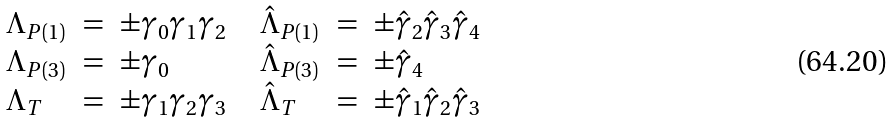<formula> <loc_0><loc_0><loc_500><loc_500>\begin{array} { l c l c l c l } \Lambda _ { P ( 1 ) } & = & \pm \gamma _ { 0 } \gamma _ { 1 } \gamma _ { 2 } & & \hat { \Lambda } _ { P ( 1 ) } & = & \pm \hat { \gamma } _ { 2 } \hat { \gamma } _ { 3 } \hat { \gamma } _ { 4 } \\ \Lambda _ { P ( 3 ) } & = & \pm \gamma _ { 0 } & & \hat { \Lambda } _ { P ( 3 ) } & = & \pm \hat { \gamma } _ { 4 } \\ \Lambda _ { T } & = & \pm \gamma _ { 1 } \gamma _ { 2 } \gamma _ { 3 } & & \hat { \Lambda } _ { T } & = & \pm \hat { \gamma } _ { 1 } \hat { \gamma } _ { 2 } \hat { \gamma } _ { 3 } \\ \end{array}</formula> 